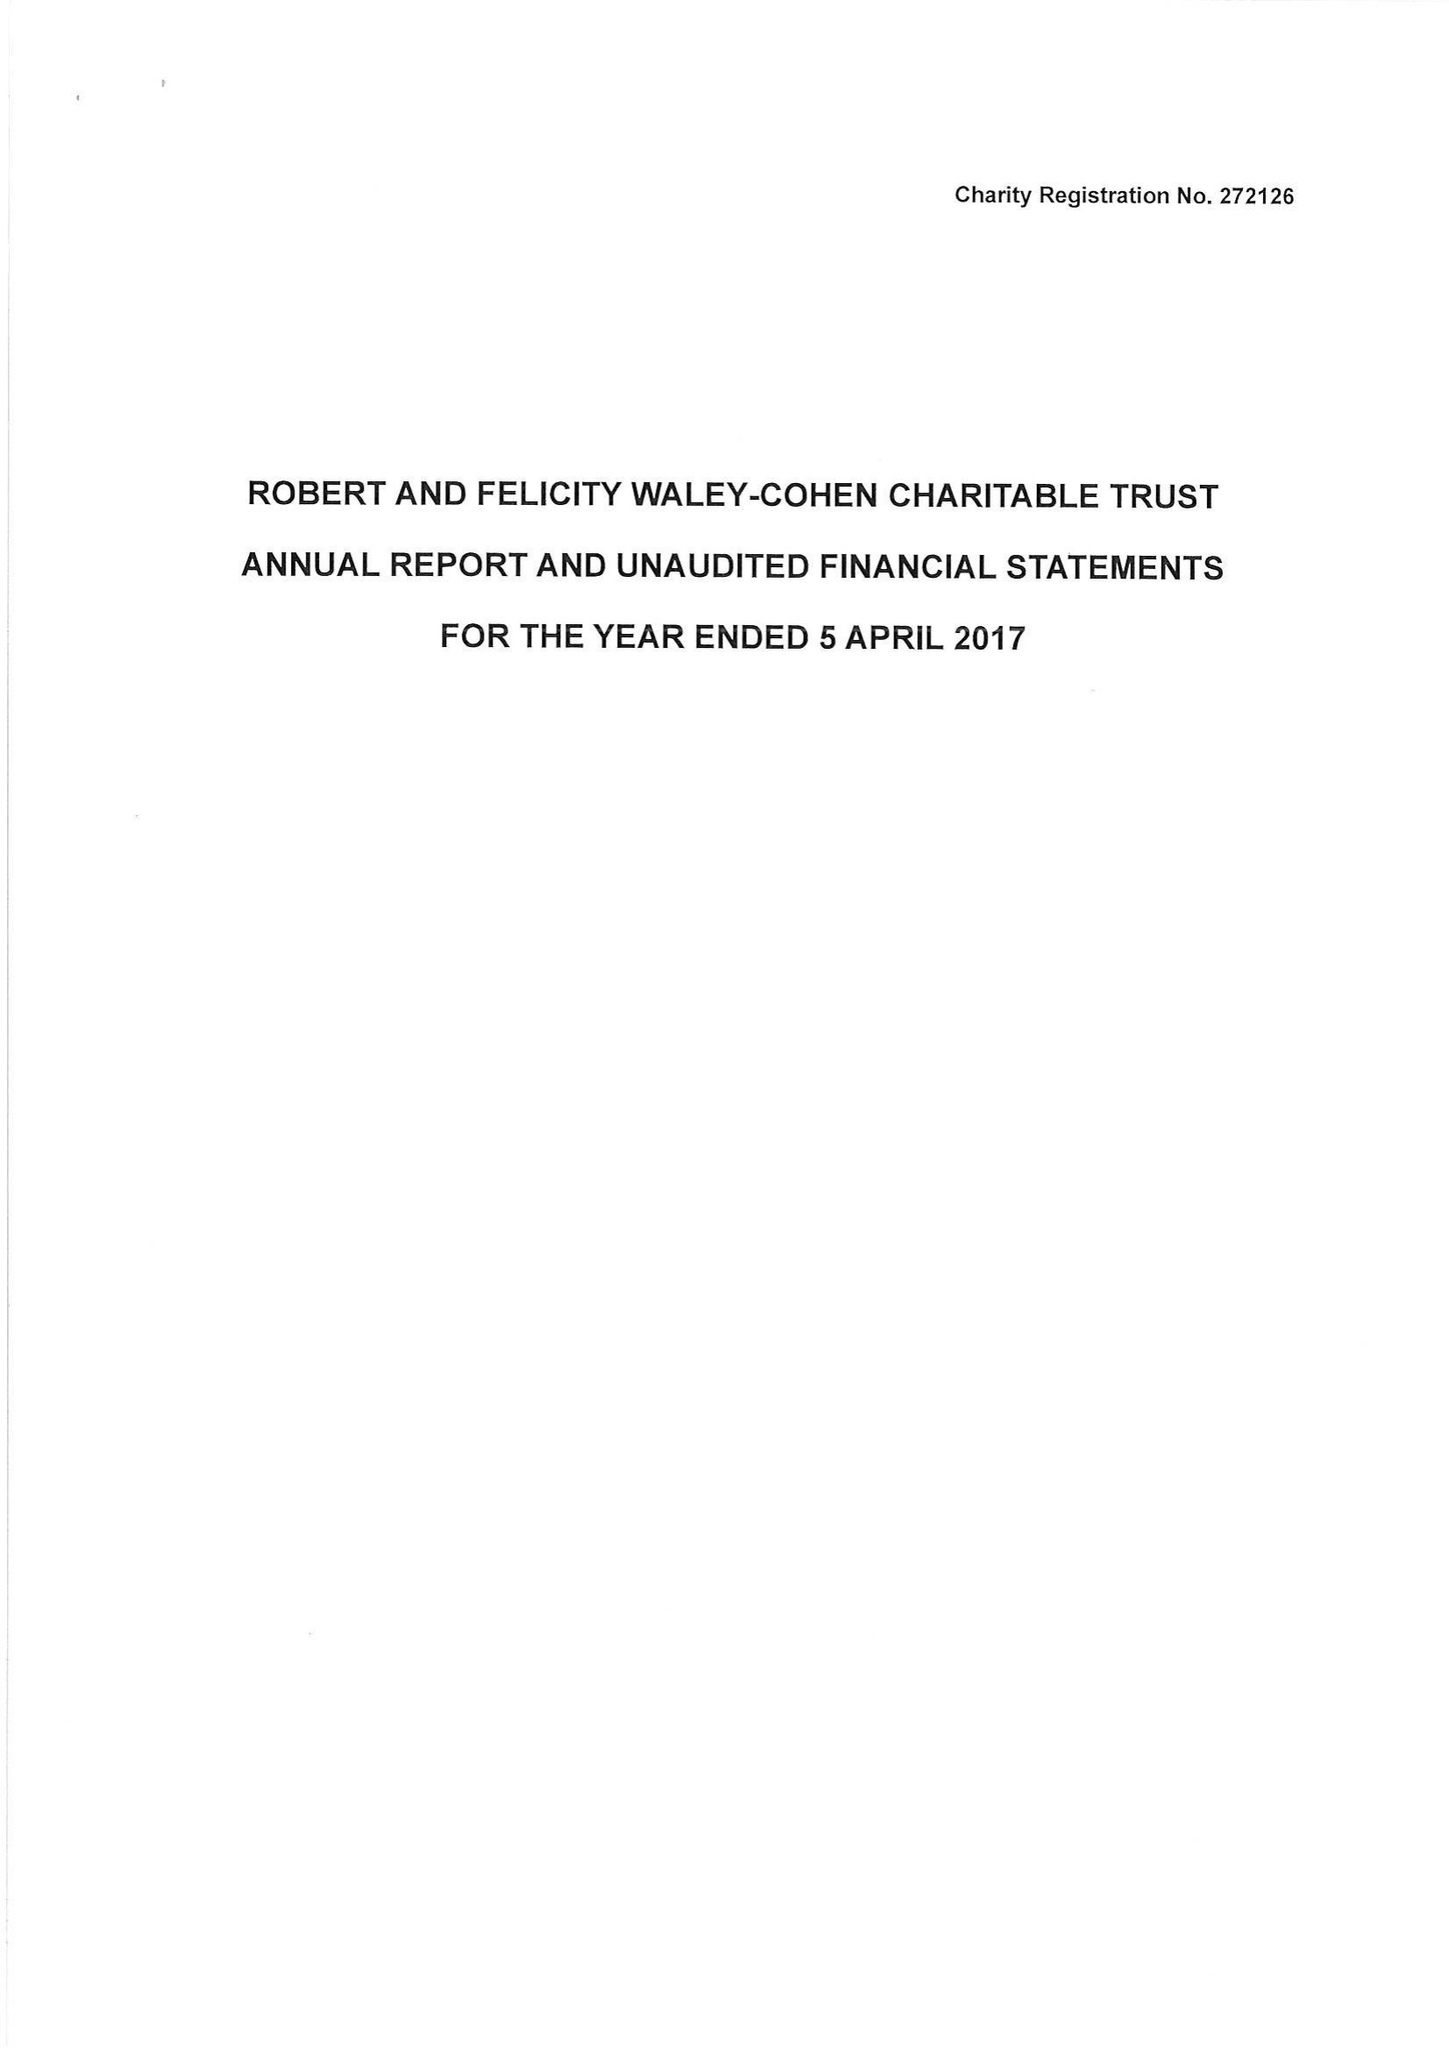What is the value for the charity_number?
Answer the question using a single word or phrase. 272126 